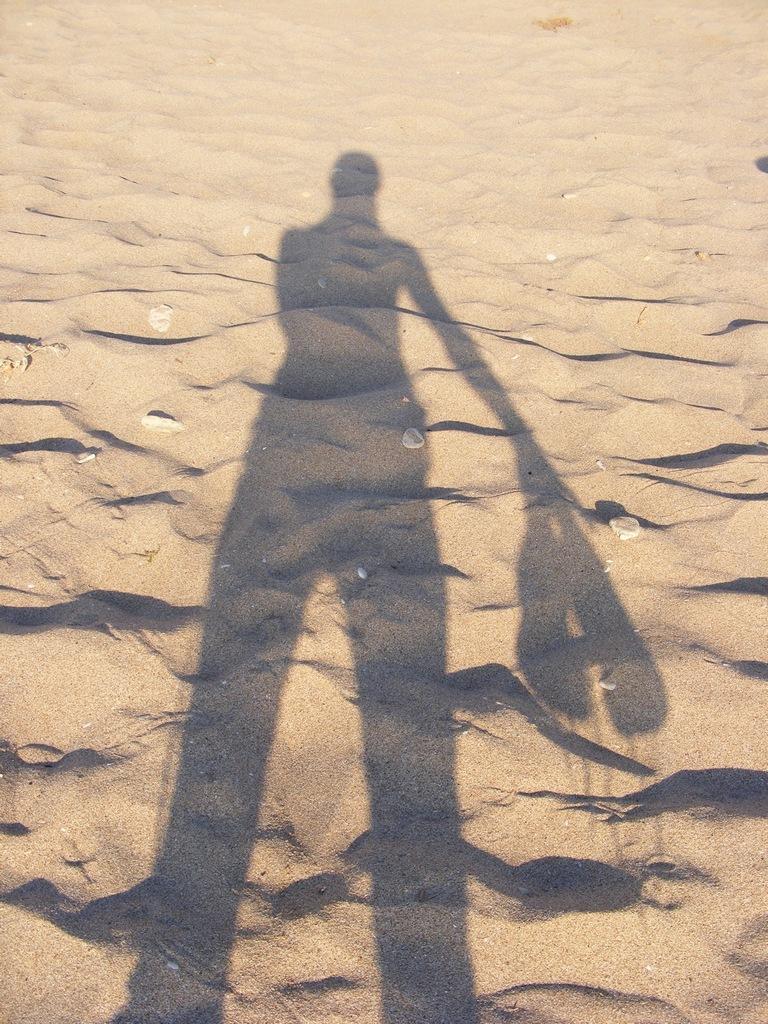Describe this image in one or two sentences. In this image, we can see a person shadow on the sand. 